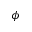<formula> <loc_0><loc_0><loc_500><loc_500>\phi</formula> 